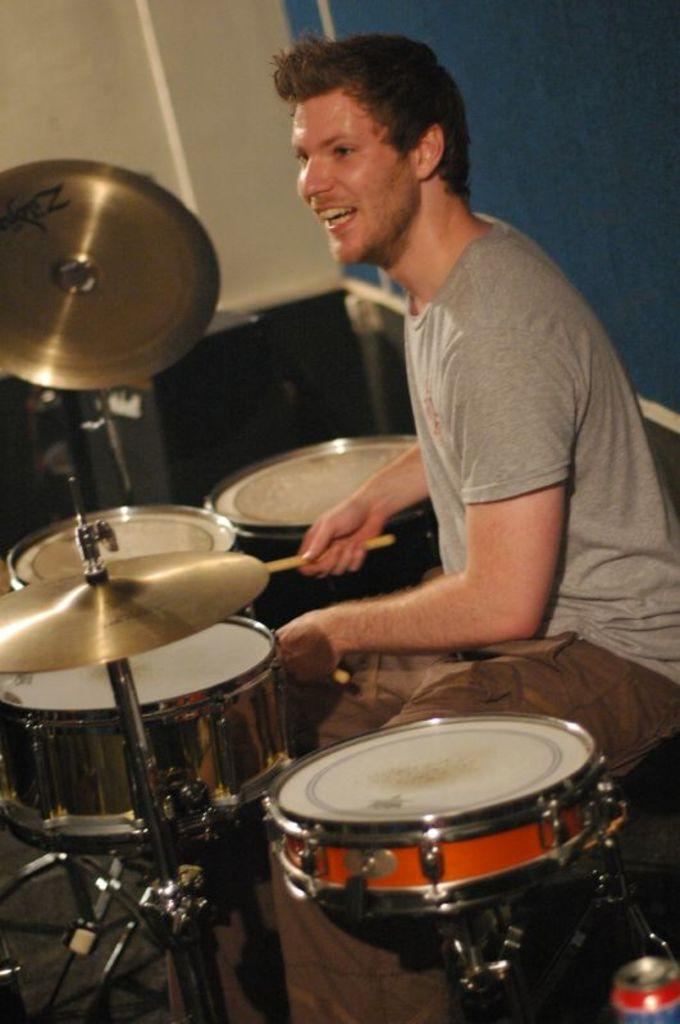What is the man in the image doing? The man is playing drums. What position is the man in while playing drums? The man is sitting. What color is the man's t-shirt? The man is wearing a grey t-shirt. What color are the man's pants? The man is wearing brown pants. What can be seen in the background of the image? There is a blue, white, and black color wall in the background of the image. How many flies can be seen on the man's forehead in the image? There are no flies visible on the man's forehead in the image. What type of organization is the man representing in the image? There is no indication of any organization in the image; it simply shows a man playing drums. 